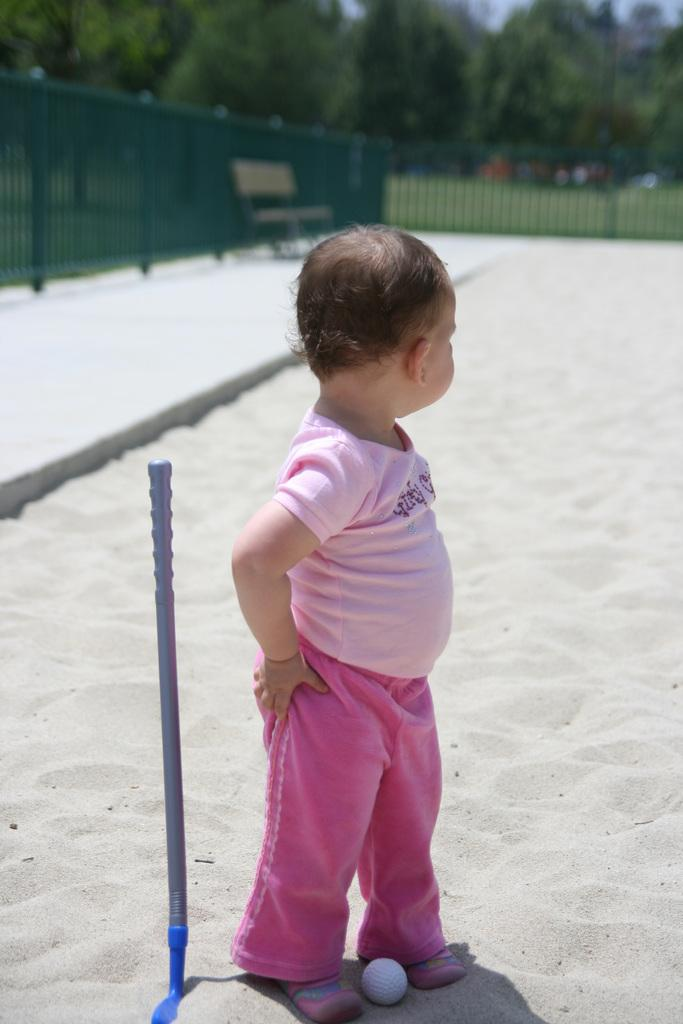What is the kid doing in the image? The kid is standing on a stand in the image. What object is in front of the kid? There is a ball in front of the kid. What can be seen in the image besides the kid and the ball? There is a metal rod in the image. What is visible in the background of the image? There is a fence, a bench, and trees in the background of the image. What type of cushion is the woman sitting on in the image? There is no woman present in the image, so it is not possible to answer the question about a cushion. 